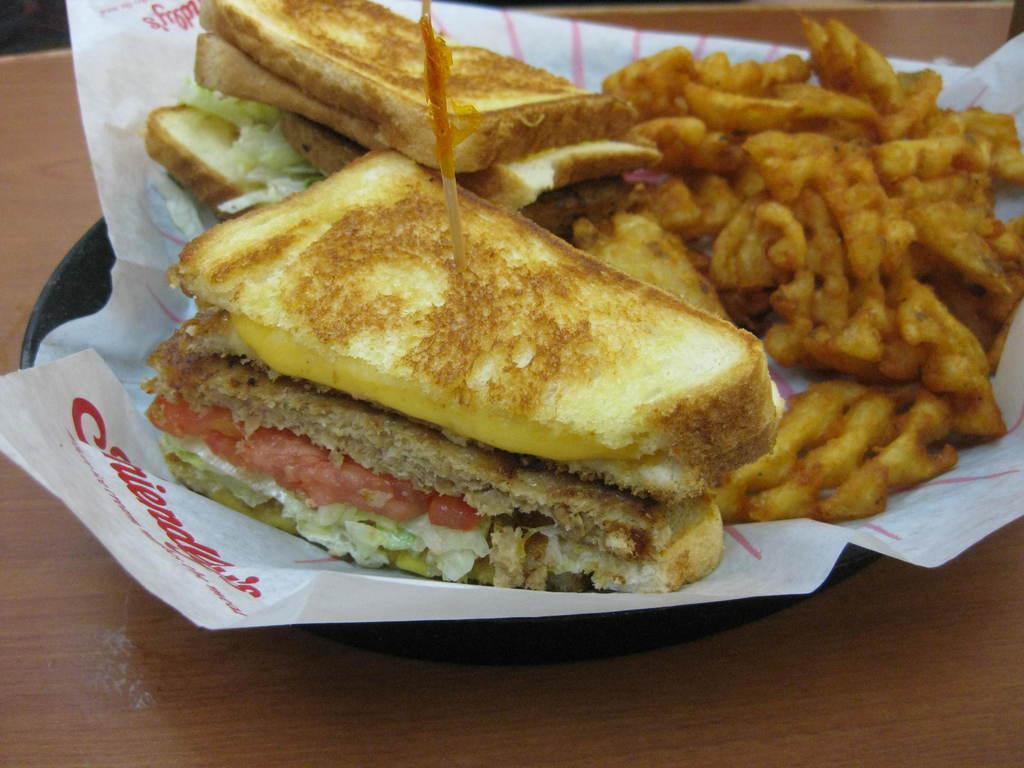In one or two sentences, can you explain what this image depicts? In this picture we can see food items and a paper in the plate and this plate is placed on the wooden platform. 